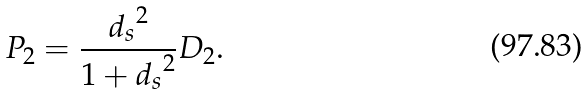<formula> <loc_0><loc_0><loc_500><loc_500>P _ { 2 } = \frac { { d _ { s } } ^ { 2 } } { 1 + { d _ { s } } ^ { 2 } } D _ { 2 } .</formula> 